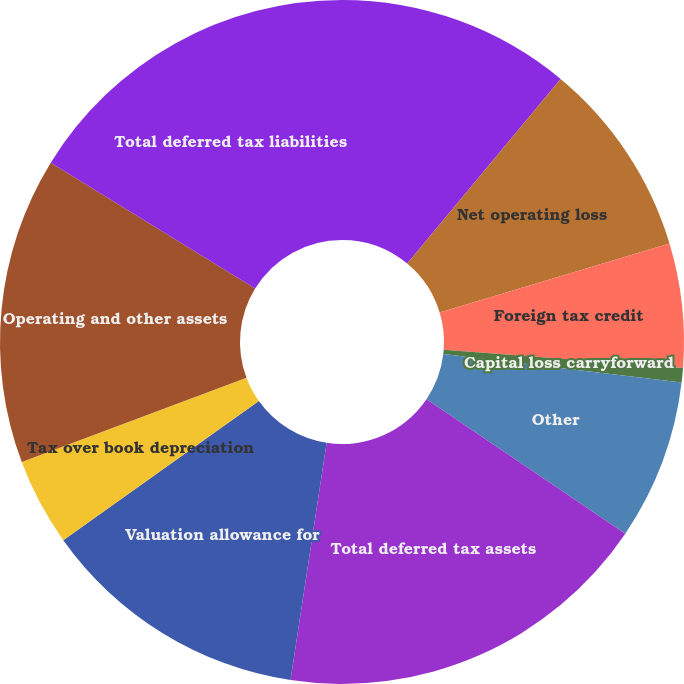<chart> <loc_0><loc_0><loc_500><loc_500><pie_chart><fcel>Allowances and operating<fcel>Net operating loss<fcel>Foreign tax credit<fcel>Capital loss carryforward<fcel>Other<fcel>Total deferred tax assets<fcel>Valuation allowance for<fcel>Tax over book depreciation<fcel>Operating and other assets<fcel>Total deferred tax liabilities<nl><fcel>11.04%<fcel>9.31%<fcel>5.86%<fcel>0.68%<fcel>7.58%<fcel>17.94%<fcel>12.76%<fcel>4.13%<fcel>14.49%<fcel>16.22%<nl></chart> 